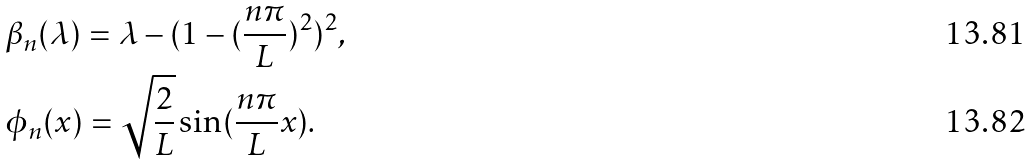<formula> <loc_0><loc_0><loc_500><loc_500>& \beta _ { n } ( \lambda ) = \lambda - ( 1 - ( \frac { n \pi } { L } ) ^ { 2 } ) ^ { 2 } , \\ & \phi _ { n } ( x ) = \sqrt { \frac { 2 } { L } } \sin ( \frac { n \pi } { L } x ) .</formula> 